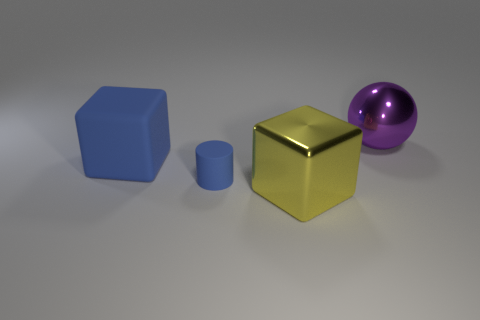Add 3 big things. How many objects exist? 7 Subtract all cylinders. How many objects are left? 3 Subtract all small cylinders. Subtract all large yellow metallic blocks. How many objects are left? 2 Add 4 purple shiny things. How many purple shiny things are left? 5 Add 1 purple rubber spheres. How many purple rubber spheres exist? 1 Subtract 0 green spheres. How many objects are left? 4 